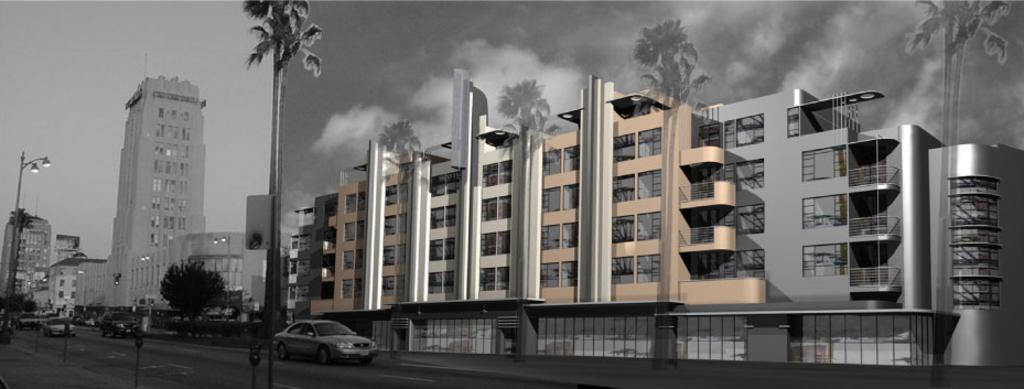What type of structures can be seen in the image? There are buildings in the image. What other natural elements are present in the image? There are trees in the image. Are there any man-made objects visible besides the buildings? Yes, there are vehicles in the image. What is the source of light in the image? There is a street lamp in the image. What can be seen in the sky in the image? The sky is visible in the image, and there are clouds in the sky. What type of rice is being cooked in the image? There is no rice present in the image. What is the chance of rain in the image? The image does not provide any information about the weather or the chance of rain. 